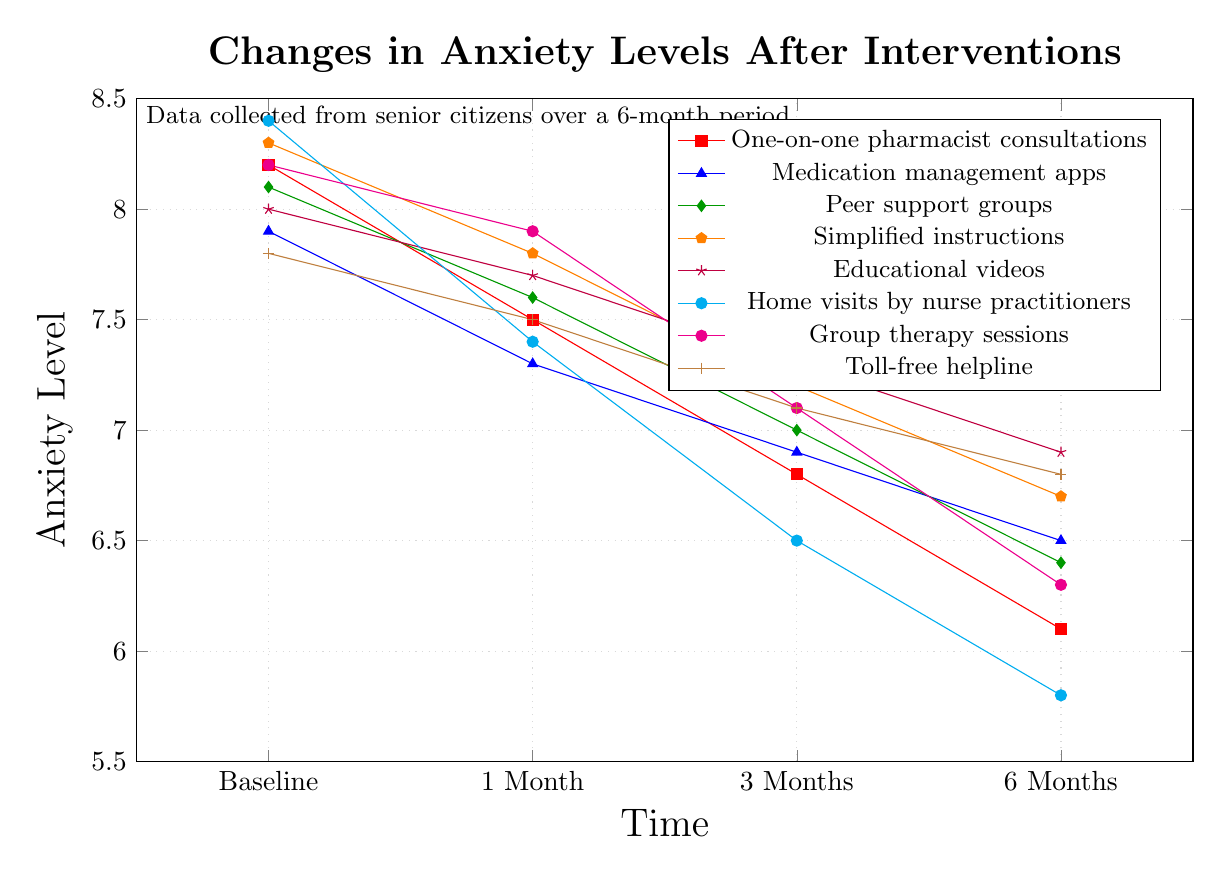Which intervention shows the largest reduction in anxiety levels from baseline to 6 months? First, identify the anxiety levels at baseline and 6 months for each intervention. Then, calculate the difference for each intervention and determine which has the largest reduction. "Home visits by nurse practitioners" has the largest reduction: 8.4 - 5.8 = 2.6
Answer: Home visits by nurse practitioners What is the average anxiety level at baseline for all interventions? Sum the baseline anxiety levels for all interventions and then divide by the number of interventions: (8.2 + 7.9 + 8.1 + 8.3 + 8.0 + 8.4 + 8.2 + 7.8) / 8 = 8.11
Answer: 8.1 Which intervention had the least change in anxiety level from baseline to 1 month? Calculate the difference between baseline and 1 month for each intervention, and identify which one has the smallest difference. "Educational videos on medication benefits" has the smallest change: 8.0 - 7.7 = 0.3
Answer: Educational videos on medication benefits How do the anxiety levels at 3 months compare between "peer support groups" and "group therapy sessions"? Look at the anxiety levels for both interventions at 3 months and compare them. "Peer support groups" has an anxiety level of 7.0 and "group therapy sessions" has 7.1. So, 7.0 < 7.1.
Answer: Peer support groups have lower anxiety levels than group therapy sessions Which intervention had the highest anxiety level at 6 months? Identify the anxiety levels at 6 months for all interventions and find the highest one. "Educational videos on medication benefits" have the highest anxiety level at 6 months: 6.9.
Answer: Educational videos on medication benefits What is the average reduction in anxiety levels from the baseline to 6 months for all interventions? Calculate the reduction for each intervention, sum them up, and divide by the number of interventions. The reductions are 2.1, 1.4, 1.7, 1.6, 1.1, 2.6, 1.9, and 1.0. Sum = 13.4; average = 13.4 / 8 = 1.675
Answer: 1.7 Which intervention shows a consistent reduction in anxiety levels at each time interval? Check which intervention shows a decreasing trend at each recorded interval. "Home visits by nurse practitioners" show a consistent reduction: 8.4 -> 7.4 -> 6.5 -> 5.8
Answer: Home visits by nurse practitioners At 1 month, which intervention has a lower anxiety level: "Toll-free helpline for medication questions" or "Medication management apps with reminders"? Check the anxiety levels for both interventions at 1 month. "Toll-free helpline for medication questions" is 7.5; "Medication management apps with reminders" is 7.3. So, 7.5 > 7.3.
Answer: Medication management apps with reminders Compare the reduction in anxiety levels from 1 month to 6 months for "Peer support groups" and "Simplified medication instructions with large print". Calculate the reductions for both interventions from 1 month to 6 months. "Peer support groups": 7.6 - 6.4 = 1.2; "Simplified medication instructions with large print": 7.8 - 6.7 = 1.1. So, 1.2 > 1.1.
Answer: Peer support groups From baseline to 6 months, which intervention has the smallest reduction in anxiety levels? Calculate the difference between baseline and 6 months for each intervention and find the smallest one. "Toll-free helpline for medication questions" has the smallest reduction: 7.8 - 6.8 = 1.0
Answer: Toll-free helpline for medication questions 